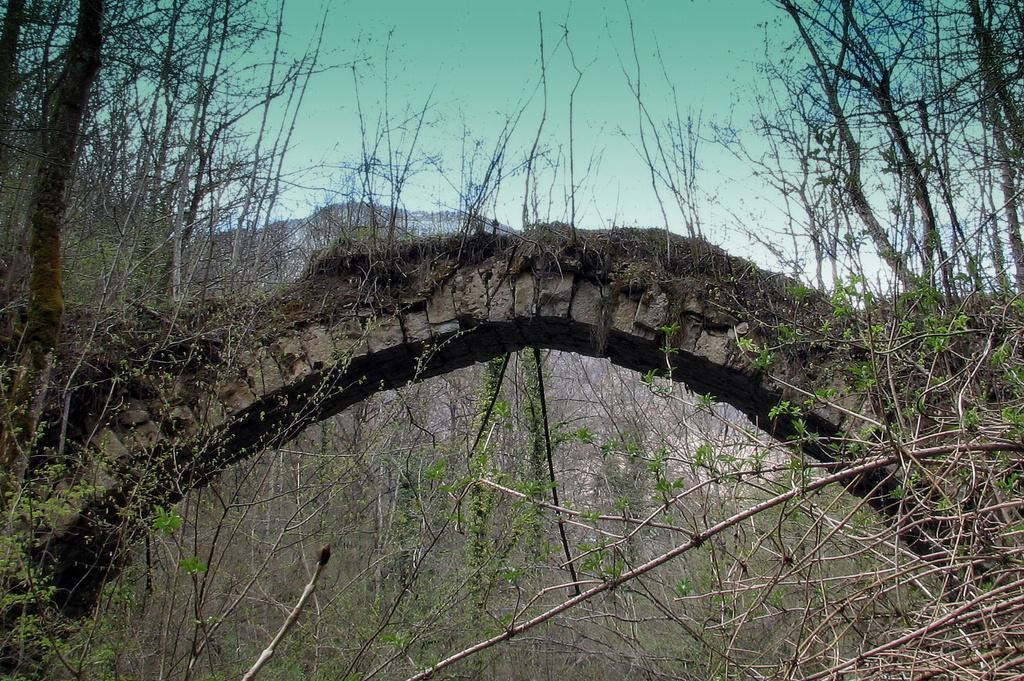How would you summarize this image in a sentence or two? In this image, there is a bridge and there are some plants and trees, at the top there is a blue color sky. 